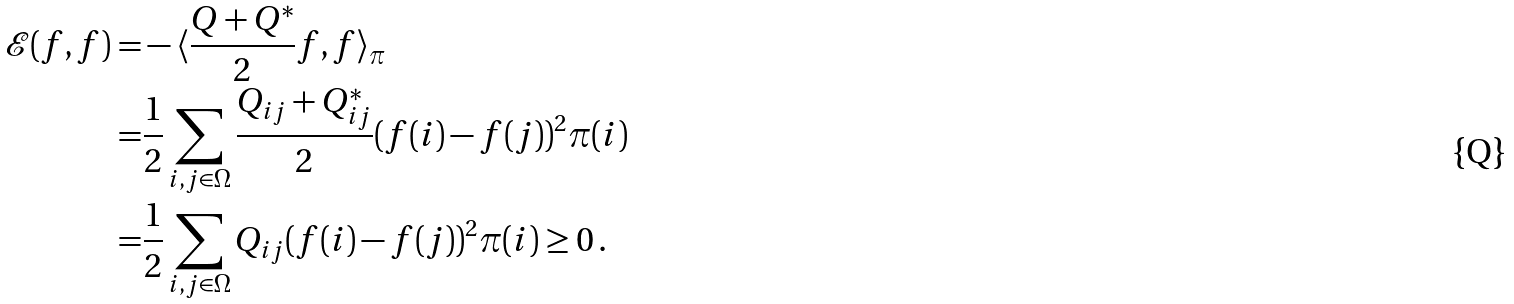<formula> <loc_0><loc_0><loc_500><loc_500>\mathcal { E } ( f , f ) = & - \langle \frac { Q + Q ^ { * } } { 2 } f , f \rangle _ { \pi } \\ = & \frac { 1 } { 2 } \sum _ { i , j \in \Omega } \frac { Q _ { i j } + Q ^ { * } _ { i j } } { 2 } ( f ( i ) - f ( j ) ) ^ { 2 } \pi ( i ) \\ = & \frac { 1 } { 2 } \sum _ { i , j \in \Omega } Q _ { i j } ( f ( i ) - f ( j ) ) ^ { 2 } \pi ( i ) \geq 0 \, .</formula> 